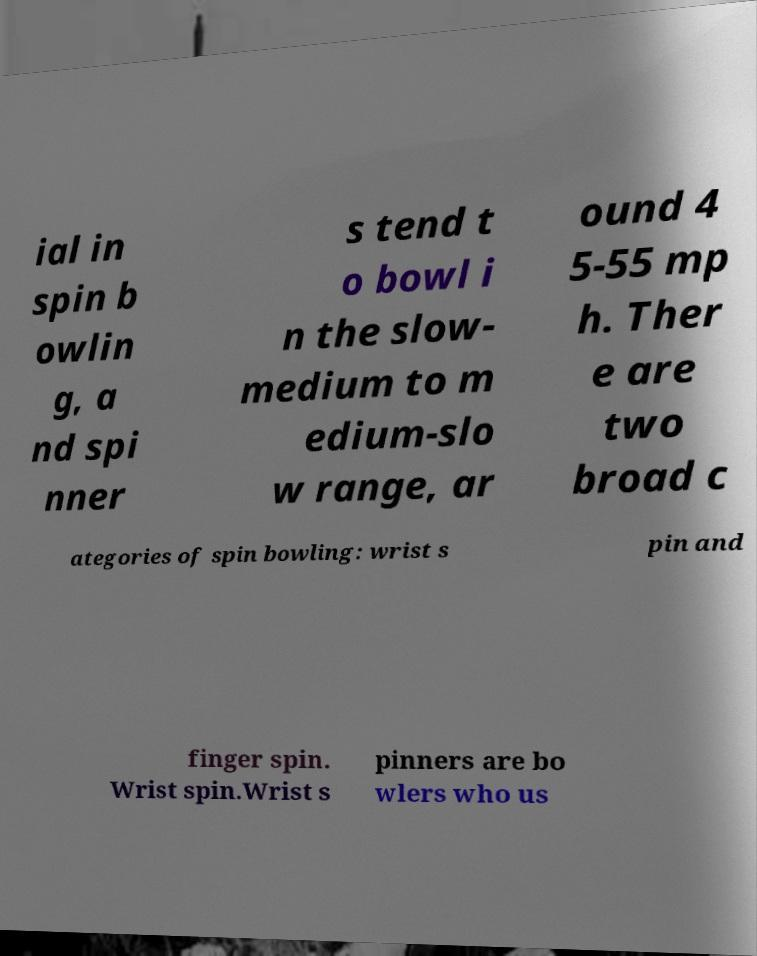Can you accurately transcribe the text from the provided image for me? ial in spin b owlin g, a nd spi nner s tend t o bowl i n the slow- medium to m edium-slo w range, ar ound 4 5-55 mp h. Ther e are two broad c ategories of spin bowling: wrist s pin and finger spin. Wrist spin.Wrist s pinners are bo wlers who us 